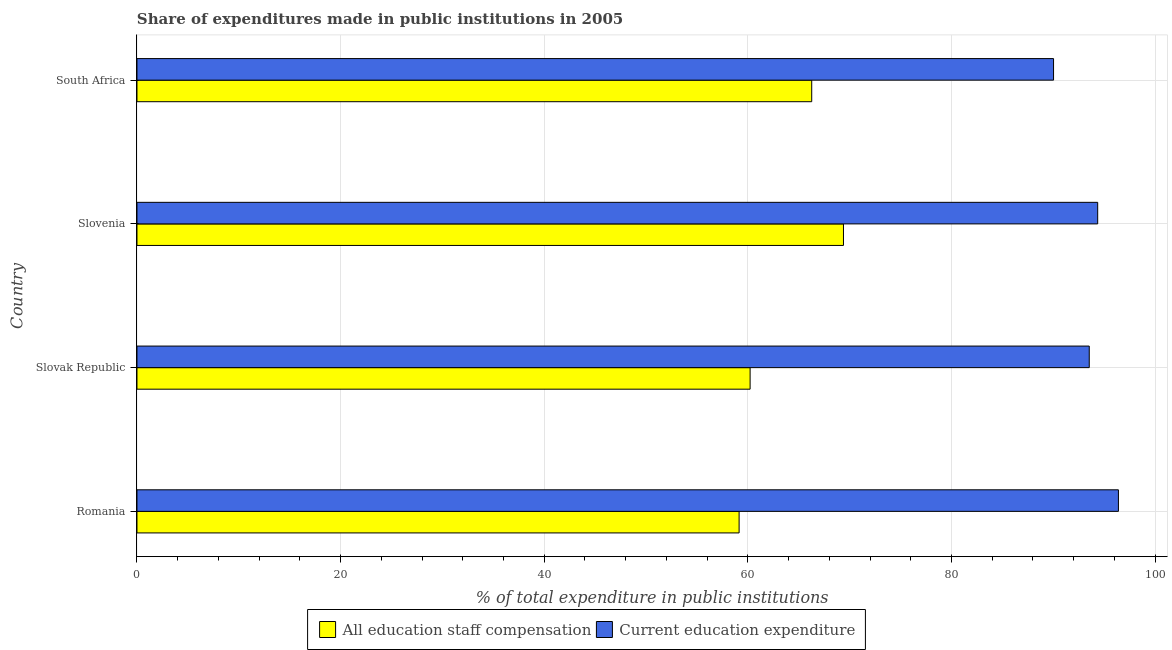How many groups of bars are there?
Your response must be concise. 4. Are the number of bars per tick equal to the number of legend labels?
Ensure brevity in your answer.  Yes. How many bars are there on the 2nd tick from the top?
Offer a very short reply. 2. How many bars are there on the 2nd tick from the bottom?
Provide a short and direct response. 2. What is the label of the 1st group of bars from the top?
Make the answer very short. South Africa. In how many cases, is the number of bars for a given country not equal to the number of legend labels?
Offer a very short reply. 0. What is the expenditure in education in Romania?
Provide a short and direct response. 96.4. Across all countries, what is the maximum expenditure in staff compensation?
Ensure brevity in your answer.  69.39. Across all countries, what is the minimum expenditure in staff compensation?
Your response must be concise. 59.14. In which country was the expenditure in education maximum?
Give a very brief answer. Romania. In which country was the expenditure in education minimum?
Keep it short and to the point. South Africa. What is the total expenditure in education in the graph?
Your answer should be very brief. 374.33. What is the difference between the expenditure in education in Slovenia and that in South Africa?
Give a very brief answer. 4.34. What is the difference between the expenditure in education in Slovak Republic and the expenditure in staff compensation in Romania?
Make the answer very short. 34.39. What is the average expenditure in staff compensation per country?
Offer a very short reply. 63.76. What is the difference between the expenditure in staff compensation and expenditure in education in Slovak Republic?
Your response must be concise. -33.31. What is the ratio of the expenditure in staff compensation in Slovenia to that in South Africa?
Keep it short and to the point. 1.05. Is the difference between the expenditure in staff compensation in Romania and Slovenia greater than the difference between the expenditure in education in Romania and Slovenia?
Your answer should be very brief. No. What is the difference between the highest and the second highest expenditure in staff compensation?
Make the answer very short. 3.12. What is the difference between the highest and the lowest expenditure in staff compensation?
Give a very brief answer. 10.25. Is the sum of the expenditure in education in Slovenia and South Africa greater than the maximum expenditure in staff compensation across all countries?
Provide a short and direct response. Yes. What does the 1st bar from the top in Slovak Republic represents?
Provide a succinct answer. Current education expenditure. What does the 1st bar from the bottom in Slovenia represents?
Provide a short and direct response. All education staff compensation. How many bars are there?
Keep it short and to the point. 8. Are all the bars in the graph horizontal?
Your answer should be very brief. Yes. What is the difference between two consecutive major ticks on the X-axis?
Your answer should be compact. 20. Where does the legend appear in the graph?
Offer a very short reply. Bottom center. What is the title of the graph?
Make the answer very short. Share of expenditures made in public institutions in 2005. Does "Forest land" appear as one of the legend labels in the graph?
Keep it short and to the point. No. What is the label or title of the X-axis?
Give a very brief answer. % of total expenditure in public institutions. What is the label or title of the Y-axis?
Offer a very short reply. Country. What is the % of total expenditure in public institutions of All education staff compensation in Romania?
Provide a short and direct response. 59.14. What is the % of total expenditure in public institutions of Current education expenditure in Romania?
Offer a terse response. 96.4. What is the % of total expenditure in public institutions in All education staff compensation in Slovak Republic?
Your answer should be very brief. 60.22. What is the % of total expenditure in public institutions in Current education expenditure in Slovak Republic?
Provide a succinct answer. 93.54. What is the % of total expenditure in public institutions in All education staff compensation in Slovenia?
Keep it short and to the point. 69.39. What is the % of total expenditure in public institutions in Current education expenditure in Slovenia?
Make the answer very short. 94.36. What is the % of total expenditure in public institutions in All education staff compensation in South Africa?
Offer a very short reply. 66.28. What is the % of total expenditure in public institutions in Current education expenditure in South Africa?
Provide a short and direct response. 90.03. Across all countries, what is the maximum % of total expenditure in public institutions in All education staff compensation?
Offer a very short reply. 69.39. Across all countries, what is the maximum % of total expenditure in public institutions of Current education expenditure?
Provide a succinct answer. 96.4. Across all countries, what is the minimum % of total expenditure in public institutions in All education staff compensation?
Give a very brief answer. 59.14. Across all countries, what is the minimum % of total expenditure in public institutions of Current education expenditure?
Your answer should be compact. 90.03. What is the total % of total expenditure in public institutions of All education staff compensation in the graph?
Your answer should be very brief. 255.04. What is the total % of total expenditure in public institutions of Current education expenditure in the graph?
Your response must be concise. 374.33. What is the difference between the % of total expenditure in public institutions of All education staff compensation in Romania and that in Slovak Republic?
Your response must be concise. -1.08. What is the difference between the % of total expenditure in public institutions of Current education expenditure in Romania and that in Slovak Republic?
Provide a short and direct response. 2.87. What is the difference between the % of total expenditure in public institutions of All education staff compensation in Romania and that in Slovenia?
Give a very brief answer. -10.25. What is the difference between the % of total expenditure in public institutions of Current education expenditure in Romania and that in Slovenia?
Give a very brief answer. 2.04. What is the difference between the % of total expenditure in public institutions of All education staff compensation in Romania and that in South Africa?
Offer a very short reply. -7.13. What is the difference between the % of total expenditure in public institutions of Current education expenditure in Romania and that in South Africa?
Provide a succinct answer. 6.37. What is the difference between the % of total expenditure in public institutions in All education staff compensation in Slovak Republic and that in Slovenia?
Offer a terse response. -9.17. What is the difference between the % of total expenditure in public institutions of Current education expenditure in Slovak Republic and that in Slovenia?
Ensure brevity in your answer.  -0.83. What is the difference between the % of total expenditure in public institutions of All education staff compensation in Slovak Republic and that in South Africa?
Ensure brevity in your answer.  -6.05. What is the difference between the % of total expenditure in public institutions of Current education expenditure in Slovak Republic and that in South Africa?
Ensure brevity in your answer.  3.51. What is the difference between the % of total expenditure in public institutions in All education staff compensation in Slovenia and that in South Africa?
Make the answer very short. 3.12. What is the difference between the % of total expenditure in public institutions of Current education expenditure in Slovenia and that in South Africa?
Your answer should be very brief. 4.34. What is the difference between the % of total expenditure in public institutions of All education staff compensation in Romania and the % of total expenditure in public institutions of Current education expenditure in Slovak Republic?
Your answer should be very brief. -34.39. What is the difference between the % of total expenditure in public institutions of All education staff compensation in Romania and the % of total expenditure in public institutions of Current education expenditure in Slovenia?
Give a very brief answer. -35.22. What is the difference between the % of total expenditure in public institutions in All education staff compensation in Romania and the % of total expenditure in public institutions in Current education expenditure in South Africa?
Your response must be concise. -30.88. What is the difference between the % of total expenditure in public institutions in All education staff compensation in Slovak Republic and the % of total expenditure in public institutions in Current education expenditure in Slovenia?
Provide a succinct answer. -34.14. What is the difference between the % of total expenditure in public institutions of All education staff compensation in Slovak Republic and the % of total expenditure in public institutions of Current education expenditure in South Africa?
Provide a short and direct response. -29.8. What is the difference between the % of total expenditure in public institutions of All education staff compensation in Slovenia and the % of total expenditure in public institutions of Current education expenditure in South Africa?
Make the answer very short. -20.63. What is the average % of total expenditure in public institutions in All education staff compensation per country?
Make the answer very short. 63.76. What is the average % of total expenditure in public institutions of Current education expenditure per country?
Keep it short and to the point. 93.58. What is the difference between the % of total expenditure in public institutions in All education staff compensation and % of total expenditure in public institutions in Current education expenditure in Romania?
Your response must be concise. -37.26. What is the difference between the % of total expenditure in public institutions of All education staff compensation and % of total expenditure in public institutions of Current education expenditure in Slovak Republic?
Your answer should be very brief. -33.31. What is the difference between the % of total expenditure in public institutions of All education staff compensation and % of total expenditure in public institutions of Current education expenditure in Slovenia?
Give a very brief answer. -24.97. What is the difference between the % of total expenditure in public institutions in All education staff compensation and % of total expenditure in public institutions in Current education expenditure in South Africa?
Your answer should be compact. -23.75. What is the ratio of the % of total expenditure in public institutions in All education staff compensation in Romania to that in Slovak Republic?
Your answer should be very brief. 0.98. What is the ratio of the % of total expenditure in public institutions in Current education expenditure in Romania to that in Slovak Republic?
Provide a succinct answer. 1.03. What is the ratio of the % of total expenditure in public institutions of All education staff compensation in Romania to that in Slovenia?
Keep it short and to the point. 0.85. What is the ratio of the % of total expenditure in public institutions of Current education expenditure in Romania to that in Slovenia?
Your response must be concise. 1.02. What is the ratio of the % of total expenditure in public institutions of All education staff compensation in Romania to that in South Africa?
Make the answer very short. 0.89. What is the ratio of the % of total expenditure in public institutions of Current education expenditure in Romania to that in South Africa?
Provide a short and direct response. 1.07. What is the ratio of the % of total expenditure in public institutions in All education staff compensation in Slovak Republic to that in Slovenia?
Make the answer very short. 0.87. What is the ratio of the % of total expenditure in public institutions in All education staff compensation in Slovak Republic to that in South Africa?
Keep it short and to the point. 0.91. What is the ratio of the % of total expenditure in public institutions of Current education expenditure in Slovak Republic to that in South Africa?
Offer a very short reply. 1.04. What is the ratio of the % of total expenditure in public institutions in All education staff compensation in Slovenia to that in South Africa?
Your answer should be very brief. 1.05. What is the ratio of the % of total expenditure in public institutions of Current education expenditure in Slovenia to that in South Africa?
Offer a very short reply. 1.05. What is the difference between the highest and the second highest % of total expenditure in public institutions of All education staff compensation?
Make the answer very short. 3.12. What is the difference between the highest and the second highest % of total expenditure in public institutions in Current education expenditure?
Your answer should be compact. 2.04. What is the difference between the highest and the lowest % of total expenditure in public institutions in All education staff compensation?
Provide a short and direct response. 10.25. What is the difference between the highest and the lowest % of total expenditure in public institutions of Current education expenditure?
Your answer should be very brief. 6.37. 